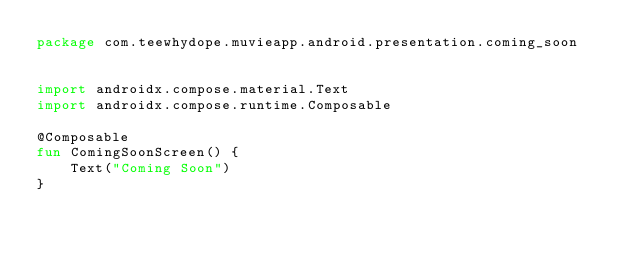<code> <loc_0><loc_0><loc_500><loc_500><_Kotlin_>package com.teewhydope.muvieapp.android.presentation.coming_soon


import androidx.compose.material.Text
import androidx.compose.runtime.Composable

@Composable
fun ComingSoonScreen() {
    Text("Coming Soon")
}</code> 